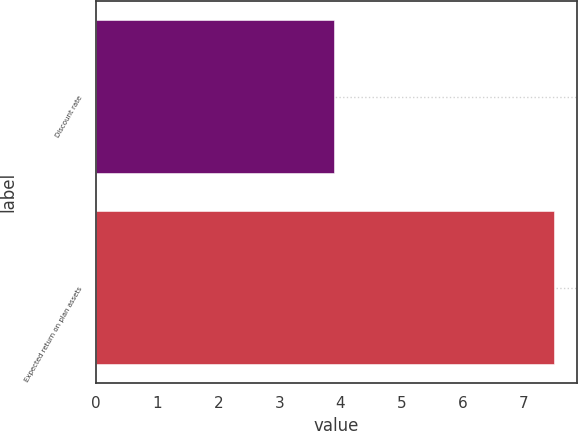Convert chart. <chart><loc_0><loc_0><loc_500><loc_500><bar_chart><fcel>Discount rate<fcel>Expected return on plan assets<nl><fcel>3.9<fcel>7.5<nl></chart> 